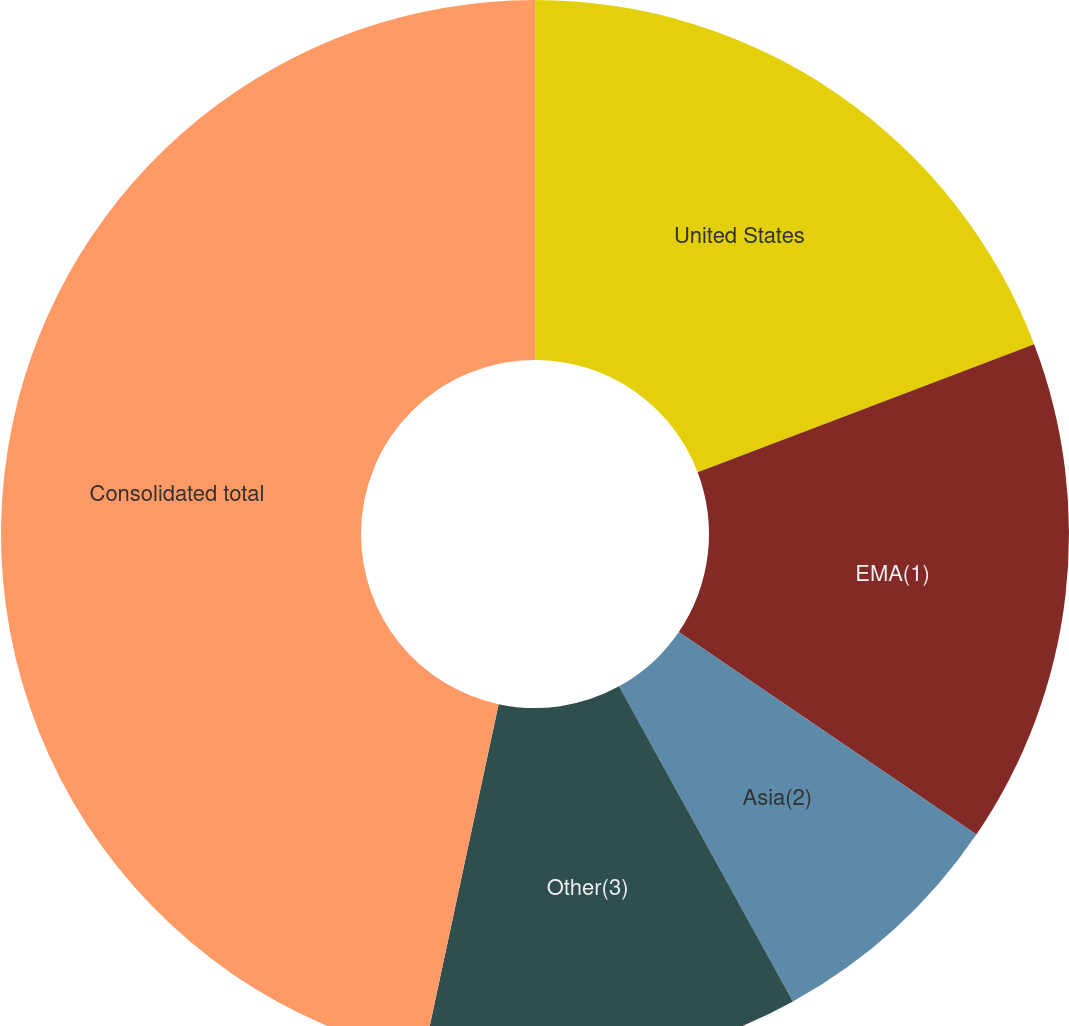Convert chart. <chart><loc_0><loc_0><loc_500><loc_500><pie_chart><fcel>United States<fcel>EMA(1)<fcel>Asia(2)<fcel>Other(3)<fcel>Consolidated total<nl><fcel>19.22%<fcel>15.3%<fcel>7.46%<fcel>11.38%<fcel>46.65%<nl></chart> 